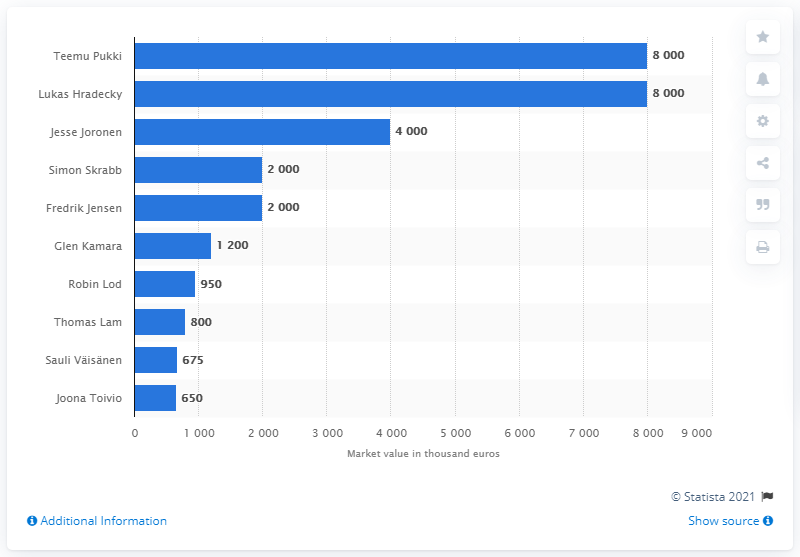Specify some key components in this picture. Simon Skrabb had a market value of two million euros. 